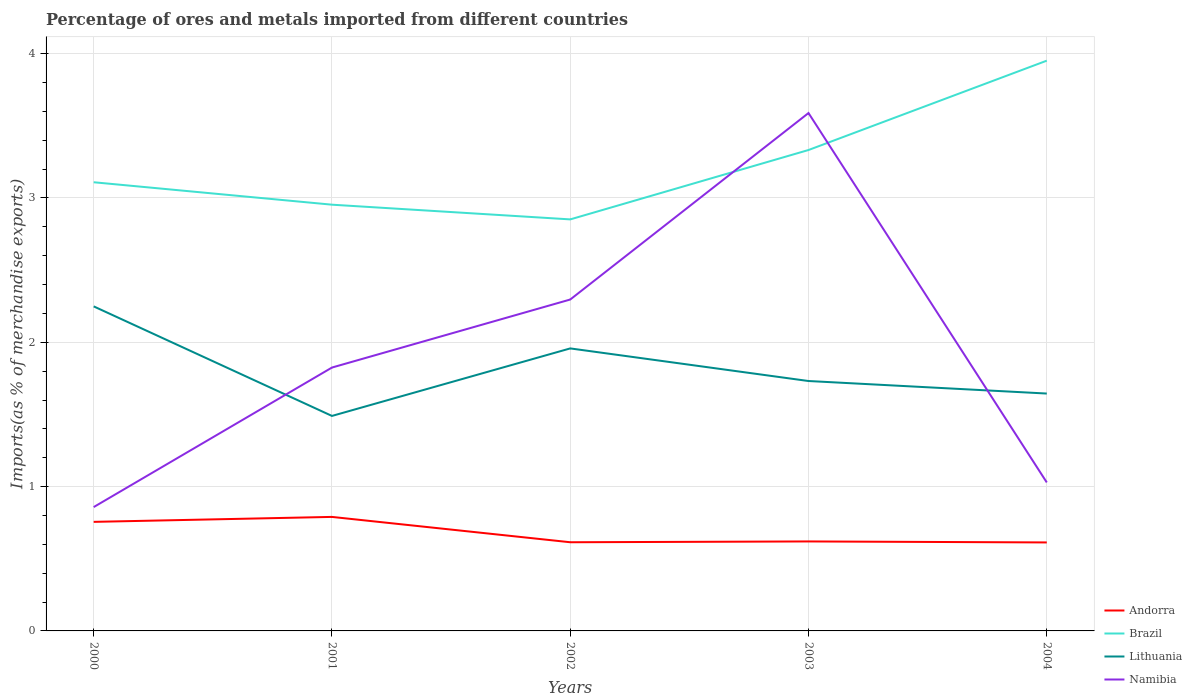How many different coloured lines are there?
Ensure brevity in your answer.  4. Does the line corresponding to Namibia intersect with the line corresponding to Brazil?
Make the answer very short. Yes. Is the number of lines equal to the number of legend labels?
Make the answer very short. Yes. Across all years, what is the maximum percentage of imports to different countries in Andorra?
Give a very brief answer. 0.61. What is the total percentage of imports to different countries in Andorra in the graph?
Ensure brevity in your answer.  0.18. What is the difference between the highest and the second highest percentage of imports to different countries in Andorra?
Provide a short and direct response. 0.18. What is the difference between the highest and the lowest percentage of imports to different countries in Lithuania?
Your response must be concise. 2. Is the percentage of imports to different countries in Lithuania strictly greater than the percentage of imports to different countries in Namibia over the years?
Keep it short and to the point. No. Are the values on the major ticks of Y-axis written in scientific E-notation?
Your answer should be compact. No. Does the graph contain any zero values?
Give a very brief answer. No. Does the graph contain grids?
Provide a succinct answer. Yes. What is the title of the graph?
Your response must be concise. Percentage of ores and metals imported from different countries. What is the label or title of the X-axis?
Provide a succinct answer. Years. What is the label or title of the Y-axis?
Your response must be concise. Imports(as % of merchandise exports). What is the Imports(as % of merchandise exports) in Andorra in 2000?
Ensure brevity in your answer.  0.76. What is the Imports(as % of merchandise exports) of Brazil in 2000?
Provide a short and direct response. 3.11. What is the Imports(as % of merchandise exports) in Lithuania in 2000?
Provide a short and direct response. 2.25. What is the Imports(as % of merchandise exports) of Namibia in 2000?
Ensure brevity in your answer.  0.86. What is the Imports(as % of merchandise exports) in Andorra in 2001?
Keep it short and to the point. 0.79. What is the Imports(as % of merchandise exports) of Brazil in 2001?
Your answer should be compact. 2.95. What is the Imports(as % of merchandise exports) of Lithuania in 2001?
Give a very brief answer. 1.49. What is the Imports(as % of merchandise exports) in Namibia in 2001?
Give a very brief answer. 1.82. What is the Imports(as % of merchandise exports) of Andorra in 2002?
Give a very brief answer. 0.61. What is the Imports(as % of merchandise exports) in Brazil in 2002?
Offer a very short reply. 2.85. What is the Imports(as % of merchandise exports) of Lithuania in 2002?
Ensure brevity in your answer.  1.96. What is the Imports(as % of merchandise exports) in Namibia in 2002?
Ensure brevity in your answer.  2.3. What is the Imports(as % of merchandise exports) of Andorra in 2003?
Give a very brief answer. 0.62. What is the Imports(as % of merchandise exports) of Brazil in 2003?
Your response must be concise. 3.33. What is the Imports(as % of merchandise exports) in Lithuania in 2003?
Ensure brevity in your answer.  1.73. What is the Imports(as % of merchandise exports) of Namibia in 2003?
Your answer should be very brief. 3.59. What is the Imports(as % of merchandise exports) of Andorra in 2004?
Give a very brief answer. 0.61. What is the Imports(as % of merchandise exports) of Brazil in 2004?
Offer a very short reply. 3.95. What is the Imports(as % of merchandise exports) of Lithuania in 2004?
Your answer should be very brief. 1.64. What is the Imports(as % of merchandise exports) in Namibia in 2004?
Make the answer very short. 1.03. Across all years, what is the maximum Imports(as % of merchandise exports) of Andorra?
Provide a succinct answer. 0.79. Across all years, what is the maximum Imports(as % of merchandise exports) in Brazil?
Make the answer very short. 3.95. Across all years, what is the maximum Imports(as % of merchandise exports) in Lithuania?
Your answer should be very brief. 2.25. Across all years, what is the maximum Imports(as % of merchandise exports) in Namibia?
Your answer should be very brief. 3.59. Across all years, what is the minimum Imports(as % of merchandise exports) of Andorra?
Ensure brevity in your answer.  0.61. Across all years, what is the minimum Imports(as % of merchandise exports) in Brazil?
Your answer should be very brief. 2.85. Across all years, what is the minimum Imports(as % of merchandise exports) of Lithuania?
Your answer should be very brief. 1.49. Across all years, what is the minimum Imports(as % of merchandise exports) of Namibia?
Keep it short and to the point. 0.86. What is the total Imports(as % of merchandise exports) of Andorra in the graph?
Give a very brief answer. 3.39. What is the total Imports(as % of merchandise exports) in Brazil in the graph?
Your response must be concise. 16.2. What is the total Imports(as % of merchandise exports) in Lithuania in the graph?
Keep it short and to the point. 9.07. What is the total Imports(as % of merchandise exports) in Namibia in the graph?
Provide a short and direct response. 9.6. What is the difference between the Imports(as % of merchandise exports) in Andorra in 2000 and that in 2001?
Make the answer very short. -0.03. What is the difference between the Imports(as % of merchandise exports) in Brazil in 2000 and that in 2001?
Your response must be concise. 0.16. What is the difference between the Imports(as % of merchandise exports) of Lithuania in 2000 and that in 2001?
Make the answer very short. 0.76. What is the difference between the Imports(as % of merchandise exports) in Namibia in 2000 and that in 2001?
Ensure brevity in your answer.  -0.97. What is the difference between the Imports(as % of merchandise exports) of Andorra in 2000 and that in 2002?
Give a very brief answer. 0.14. What is the difference between the Imports(as % of merchandise exports) of Brazil in 2000 and that in 2002?
Make the answer very short. 0.26. What is the difference between the Imports(as % of merchandise exports) of Lithuania in 2000 and that in 2002?
Offer a very short reply. 0.29. What is the difference between the Imports(as % of merchandise exports) of Namibia in 2000 and that in 2002?
Provide a short and direct response. -1.44. What is the difference between the Imports(as % of merchandise exports) of Andorra in 2000 and that in 2003?
Give a very brief answer. 0.14. What is the difference between the Imports(as % of merchandise exports) in Brazil in 2000 and that in 2003?
Offer a very short reply. -0.22. What is the difference between the Imports(as % of merchandise exports) in Lithuania in 2000 and that in 2003?
Your answer should be compact. 0.52. What is the difference between the Imports(as % of merchandise exports) of Namibia in 2000 and that in 2003?
Your answer should be compact. -2.73. What is the difference between the Imports(as % of merchandise exports) of Andorra in 2000 and that in 2004?
Your answer should be very brief. 0.14. What is the difference between the Imports(as % of merchandise exports) of Brazil in 2000 and that in 2004?
Offer a terse response. -0.84. What is the difference between the Imports(as % of merchandise exports) in Lithuania in 2000 and that in 2004?
Give a very brief answer. 0.6. What is the difference between the Imports(as % of merchandise exports) of Namibia in 2000 and that in 2004?
Provide a succinct answer. -0.17. What is the difference between the Imports(as % of merchandise exports) of Andorra in 2001 and that in 2002?
Offer a terse response. 0.18. What is the difference between the Imports(as % of merchandise exports) in Brazil in 2001 and that in 2002?
Provide a short and direct response. 0.1. What is the difference between the Imports(as % of merchandise exports) of Lithuania in 2001 and that in 2002?
Give a very brief answer. -0.47. What is the difference between the Imports(as % of merchandise exports) in Namibia in 2001 and that in 2002?
Keep it short and to the point. -0.47. What is the difference between the Imports(as % of merchandise exports) in Andorra in 2001 and that in 2003?
Offer a terse response. 0.17. What is the difference between the Imports(as % of merchandise exports) of Brazil in 2001 and that in 2003?
Ensure brevity in your answer.  -0.38. What is the difference between the Imports(as % of merchandise exports) in Lithuania in 2001 and that in 2003?
Offer a terse response. -0.24. What is the difference between the Imports(as % of merchandise exports) in Namibia in 2001 and that in 2003?
Provide a short and direct response. -1.76. What is the difference between the Imports(as % of merchandise exports) of Andorra in 2001 and that in 2004?
Keep it short and to the point. 0.18. What is the difference between the Imports(as % of merchandise exports) of Brazil in 2001 and that in 2004?
Your response must be concise. -1. What is the difference between the Imports(as % of merchandise exports) in Lithuania in 2001 and that in 2004?
Provide a short and direct response. -0.16. What is the difference between the Imports(as % of merchandise exports) in Namibia in 2001 and that in 2004?
Give a very brief answer. 0.8. What is the difference between the Imports(as % of merchandise exports) of Andorra in 2002 and that in 2003?
Your answer should be very brief. -0.01. What is the difference between the Imports(as % of merchandise exports) in Brazil in 2002 and that in 2003?
Your answer should be compact. -0.48. What is the difference between the Imports(as % of merchandise exports) of Lithuania in 2002 and that in 2003?
Your response must be concise. 0.23. What is the difference between the Imports(as % of merchandise exports) in Namibia in 2002 and that in 2003?
Your answer should be compact. -1.29. What is the difference between the Imports(as % of merchandise exports) in Andorra in 2002 and that in 2004?
Make the answer very short. 0. What is the difference between the Imports(as % of merchandise exports) of Brazil in 2002 and that in 2004?
Provide a short and direct response. -1.1. What is the difference between the Imports(as % of merchandise exports) of Lithuania in 2002 and that in 2004?
Ensure brevity in your answer.  0.31. What is the difference between the Imports(as % of merchandise exports) of Namibia in 2002 and that in 2004?
Give a very brief answer. 1.27. What is the difference between the Imports(as % of merchandise exports) in Andorra in 2003 and that in 2004?
Provide a short and direct response. 0.01. What is the difference between the Imports(as % of merchandise exports) in Brazil in 2003 and that in 2004?
Provide a succinct answer. -0.62. What is the difference between the Imports(as % of merchandise exports) of Lithuania in 2003 and that in 2004?
Your answer should be compact. 0.09. What is the difference between the Imports(as % of merchandise exports) of Namibia in 2003 and that in 2004?
Provide a succinct answer. 2.56. What is the difference between the Imports(as % of merchandise exports) in Andorra in 2000 and the Imports(as % of merchandise exports) in Brazil in 2001?
Provide a succinct answer. -2.2. What is the difference between the Imports(as % of merchandise exports) in Andorra in 2000 and the Imports(as % of merchandise exports) in Lithuania in 2001?
Give a very brief answer. -0.73. What is the difference between the Imports(as % of merchandise exports) of Andorra in 2000 and the Imports(as % of merchandise exports) of Namibia in 2001?
Give a very brief answer. -1.07. What is the difference between the Imports(as % of merchandise exports) of Brazil in 2000 and the Imports(as % of merchandise exports) of Lithuania in 2001?
Make the answer very short. 1.62. What is the difference between the Imports(as % of merchandise exports) in Brazil in 2000 and the Imports(as % of merchandise exports) in Namibia in 2001?
Provide a short and direct response. 1.28. What is the difference between the Imports(as % of merchandise exports) in Lithuania in 2000 and the Imports(as % of merchandise exports) in Namibia in 2001?
Keep it short and to the point. 0.42. What is the difference between the Imports(as % of merchandise exports) of Andorra in 2000 and the Imports(as % of merchandise exports) of Brazil in 2002?
Offer a terse response. -2.1. What is the difference between the Imports(as % of merchandise exports) of Andorra in 2000 and the Imports(as % of merchandise exports) of Lithuania in 2002?
Provide a short and direct response. -1.2. What is the difference between the Imports(as % of merchandise exports) of Andorra in 2000 and the Imports(as % of merchandise exports) of Namibia in 2002?
Ensure brevity in your answer.  -1.54. What is the difference between the Imports(as % of merchandise exports) of Brazil in 2000 and the Imports(as % of merchandise exports) of Lithuania in 2002?
Your response must be concise. 1.15. What is the difference between the Imports(as % of merchandise exports) of Brazil in 2000 and the Imports(as % of merchandise exports) of Namibia in 2002?
Provide a succinct answer. 0.81. What is the difference between the Imports(as % of merchandise exports) in Lithuania in 2000 and the Imports(as % of merchandise exports) in Namibia in 2002?
Give a very brief answer. -0.05. What is the difference between the Imports(as % of merchandise exports) of Andorra in 2000 and the Imports(as % of merchandise exports) of Brazil in 2003?
Your answer should be very brief. -2.58. What is the difference between the Imports(as % of merchandise exports) of Andorra in 2000 and the Imports(as % of merchandise exports) of Lithuania in 2003?
Ensure brevity in your answer.  -0.98. What is the difference between the Imports(as % of merchandise exports) in Andorra in 2000 and the Imports(as % of merchandise exports) in Namibia in 2003?
Your answer should be compact. -2.83. What is the difference between the Imports(as % of merchandise exports) in Brazil in 2000 and the Imports(as % of merchandise exports) in Lithuania in 2003?
Ensure brevity in your answer.  1.38. What is the difference between the Imports(as % of merchandise exports) of Brazil in 2000 and the Imports(as % of merchandise exports) of Namibia in 2003?
Offer a very short reply. -0.48. What is the difference between the Imports(as % of merchandise exports) in Lithuania in 2000 and the Imports(as % of merchandise exports) in Namibia in 2003?
Your response must be concise. -1.34. What is the difference between the Imports(as % of merchandise exports) of Andorra in 2000 and the Imports(as % of merchandise exports) of Brazil in 2004?
Provide a short and direct response. -3.2. What is the difference between the Imports(as % of merchandise exports) of Andorra in 2000 and the Imports(as % of merchandise exports) of Lithuania in 2004?
Keep it short and to the point. -0.89. What is the difference between the Imports(as % of merchandise exports) of Andorra in 2000 and the Imports(as % of merchandise exports) of Namibia in 2004?
Your response must be concise. -0.27. What is the difference between the Imports(as % of merchandise exports) in Brazil in 2000 and the Imports(as % of merchandise exports) in Lithuania in 2004?
Your response must be concise. 1.46. What is the difference between the Imports(as % of merchandise exports) of Brazil in 2000 and the Imports(as % of merchandise exports) of Namibia in 2004?
Ensure brevity in your answer.  2.08. What is the difference between the Imports(as % of merchandise exports) of Lithuania in 2000 and the Imports(as % of merchandise exports) of Namibia in 2004?
Your answer should be very brief. 1.22. What is the difference between the Imports(as % of merchandise exports) of Andorra in 2001 and the Imports(as % of merchandise exports) of Brazil in 2002?
Make the answer very short. -2.06. What is the difference between the Imports(as % of merchandise exports) in Andorra in 2001 and the Imports(as % of merchandise exports) in Lithuania in 2002?
Offer a terse response. -1.17. What is the difference between the Imports(as % of merchandise exports) in Andorra in 2001 and the Imports(as % of merchandise exports) in Namibia in 2002?
Keep it short and to the point. -1.51. What is the difference between the Imports(as % of merchandise exports) in Brazil in 2001 and the Imports(as % of merchandise exports) in Lithuania in 2002?
Offer a terse response. 1. What is the difference between the Imports(as % of merchandise exports) in Brazil in 2001 and the Imports(as % of merchandise exports) in Namibia in 2002?
Ensure brevity in your answer.  0.66. What is the difference between the Imports(as % of merchandise exports) of Lithuania in 2001 and the Imports(as % of merchandise exports) of Namibia in 2002?
Keep it short and to the point. -0.81. What is the difference between the Imports(as % of merchandise exports) in Andorra in 2001 and the Imports(as % of merchandise exports) in Brazil in 2003?
Your answer should be very brief. -2.54. What is the difference between the Imports(as % of merchandise exports) in Andorra in 2001 and the Imports(as % of merchandise exports) in Lithuania in 2003?
Give a very brief answer. -0.94. What is the difference between the Imports(as % of merchandise exports) of Andorra in 2001 and the Imports(as % of merchandise exports) of Namibia in 2003?
Make the answer very short. -2.8. What is the difference between the Imports(as % of merchandise exports) of Brazil in 2001 and the Imports(as % of merchandise exports) of Lithuania in 2003?
Your answer should be very brief. 1.22. What is the difference between the Imports(as % of merchandise exports) of Brazil in 2001 and the Imports(as % of merchandise exports) of Namibia in 2003?
Make the answer very short. -0.64. What is the difference between the Imports(as % of merchandise exports) in Lithuania in 2001 and the Imports(as % of merchandise exports) in Namibia in 2003?
Keep it short and to the point. -2.1. What is the difference between the Imports(as % of merchandise exports) of Andorra in 2001 and the Imports(as % of merchandise exports) of Brazil in 2004?
Your answer should be compact. -3.16. What is the difference between the Imports(as % of merchandise exports) in Andorra in 2001 and the Imports(as % of merchandise exports) in Lithuania in 2004?
Make the answer very short. -0.85. What is the difference between the Imports(as % of merchandise exports) of Andorra in 2001 and the Imports(as % of merchandise exports) of Namibia in 2004?
Provide a short and direct response. -0.24. What is the difference between the Imports(as % of merchandise exports) of Brazil in 2001 and the Imports(as % of merchandise exports) of Lithuania in 2004?
Make the answer very short. 1.31. What is the difference between the Imports(as % of merchandise exports) of Brazil in 2001 and the Imports(as % of merchandise exports) of Namibia in 2004?
Give a very brief answer. 1.92. What is the difference between the Imports(as % of merchandise exports) of Lithuania in 2001 and the Imports(as % of merchandise exports) of Namibia in 2004?
Ensure brevity in your answer.  0.46. What is the difference between the Imports(as % of merchandise exports) of Andorra in 2002 and the Imports(as % of merchandise exports) of Brazil in 2003?
Your answer should be very brief. -2.72. What is the difference between the Imports(as % of merchandise exports) in Andorra in 2002 and the Imports(as % of merchandise exports) in Lithuania in 2003?
Make the answer very short. -1.12. What is the difference between the Imports(as % of merchandise exports) in Andorra in 2002 and the Imports(as % of merchandise exports) in Namibia in 2003?
Provide a short and direct response. -2.97. What is the difference between the Imports(as % of merchandise exports) of Brazil in 2002 and the Imports(as % of merchandise exports) of Lithuania in 2003?
Provide a succinct answer. 1.12. What is the difference between the Imports(as % of merchandise exports) of Brazil in 2002 and the Imports(as % of merchandise exports) of Namibia in 2003?
Provide a succinct answer. -0.74. What is the difference between the Imports(as % of merchandise exports) in Lithuania in 2002 and the Imports(as % of merchandise exports) in Namibia in 2003?
Offer a terse response. -1.63. What is the difference between the Imports(as % of merchandise exports) in Andorra in 2002 and the Imports(as % of merchandise exports) in Brazil in 2004?
Give a very brief answer. -3.34. What is the difference between the Imports(as % of merchandise exports) in Andorra in 2002 and the Imports(as % of merchandise exports) in Lithuania in 2004?
Provide a short and direct response. -1.03. What is the difference between the Imports(as % of merchandise exports) in Andorra in 2002 and the Imports(as % of merchandise exports) in Namibia in 2004?
Offer a very short reply. -0.41. What is the difference between the Imports(as % of merchandise exports) of Brazil in 2002 and the Imports(as % of merchandise exports) of Lithuania in 2004?
Keep it short and to the point. 1.21. What is the difference between the Imports(as % of merchandise exports) in Brazil in 2002 and the Imports(as % of merchandise exports) in Namibia in 2004?
Provide a short and direct response. 1.82. What is the difference between the Imports(as % of merchandise exports) in Lithuania in 2002 and the Imports(as % of merchandise exports) in Namibia in 2004?
Give a very brief answer. 0.93. What is the difference between the Imports(as % of merchandise exports) of Andorra in 2003 and the Imports(as % of merchandise exports) of Brazil in 2004?
Offer a very short reply. -3.33. What is the difference between the Imports(as % of merchandise exports) in Andorra in 2003 and the Imports(as % of merchandise exports) in Lithuania in 2004?
Provide a succinct answer. -1.02. What is the difference between the Imports(as % of merchandise exports) in Andorra in 2003 and the Imports(as % of merchandise exports) in Namibia in 2004?
Keep it short and to the point. -0.41. What is the difference between the Imports(as % of merchandise exports) of Brazil in 2003 and the Imports(as % of merchandise exports) of Lithuania in 2004?
Your response must be concise. 1.69. What is the difference between the Imports(as % of merchandise exports) of Brazil in 2003 and the Imports(as % of merchandise exports) of Namibia in 2004?
Ensure brevity in your answer.  2.3. What is the difference between the Imports(as % of merchandise exports) of Lithuania in 2003 and the Imports(as % of merchandise exports) of Namibia in 2004?
Make the answer very short. 0.7. What is the average Imports(as % of merchandise exports) of Andorra per year?
Offer a terse response. 0.68. What is the average Imports(as % of merchandise exports) of Brazil per year?
Give a very brief answer. 3.24. What is the average Imports(as % of merchandise exports) in Lithuania per year?
Give a very brief answer. 1.81. What is the average Imports(as % of merchandise exports) of Namibia per year?
Give a very brief answer. 1.92. In the year 2000, what is the difference between the Imports(as % of merchandise exports) of Andorra and Imports(as % of merchandise exports) of Brazil?
Offer a very short reply. -2.35. In the year 2000, what is the difference between the Imports(as % of merchandise exports) in Andorra and Imports(as % of merchandise exports) in Lithuania?
Give a very brief answer. -1.49. In the year 2000, what is the difference between the Imports(as % of merchandise exports) in Andorra and Imports(as % of merchandise exports) in Namibia?
Keep it short and to the point. -0.1. In the year 2000, what is the difference between the Imports(as % of merchandise exports) of Brazil and Imports(as % of merchandise exports) of Lithuania?
Give a very brief answer. 0.86. In the year 2000, what is the difference between the Imports(as % of merchandise exports) in Brazil and Imports(as % of merchandise exports) in Namibia?
Your answer should be compact. 2.25. In the year 2000, what is the difference between the Imports(as % of merchandise exports) in Lithuania and Imports(as % of merchandise exports) in Namibia?
Provide a succinct answer. 1.39. In the year 2001, what is the difference between the Imports(as % of merchandise exports) of Andorra and Imports(as % of merchandise exports) of Brazil?
Offer a terse response. -2.16. In the year 2001, what is the difference between the Imports(as % of merchandise exports) of Andorra and Imports(as % of merchandise exports) of Lithuania?
Provide a succinct answer. -0.7. In the year 2001, what is the difference between the Imports(as % of merchandise exports) of Andorra and Imports(as % of merchandise exports) of Namibia?
Give a very brief answer. -1.03. In the year 2001, what is the difference between the Imports(as % of merchandise exports) in Brazil and Imports(as % of merchandise exports) in Lithuania?
Provide a succinct answer. 1.46. In the year 2001, what is the difference between the Imports(as % of merchandise exports) of Brazil and Imports(as % of merchandise exports) of Namibia?
Make the answer very short. 1.13. In the year 2001, what is the difference between the Imports(as % of merchandise exports) in Lithuania and Imports(as % of merchandise exports) in Namibia?
Ensure brevity in your answer.  -0.34. In the year 2002, what is the difference between the Imports(as % of merchandise exports) of Andorra and Imports(as % of merchandise exports) of Brazil?
Keep it short and to the point. -2.24. In the year 2002, what is the difference between the Imports(as % of merchandise exports) in Andorra and Imports(as % of merchandise exports) in Lithuania?
Offer a terse response. -1.34. In the year 2002, what is the difference between the Imports(as % of merchandise exports) of Andorra and Imports(as % of merchandise exports) of Namibia?
Your response must be concise. -1.68. In the year 2002, what is the difference between the Imports(as % of merchandise exports) of Brazil and Imports(as % of merchandise exports) of Lithuania?
Your response must be concise. 0.89. In the year 2002, what is the difference between the Imports(as % of merchandise exports) of Brazil and Imports(as % of merchandise exports) of Namibia?
Ensure brevity in your answer.  0.56. In the year 2002, what is the difference between the Imports(as % of merchandise exports) of Lithuania and Imports(as % of merchandise exports) of Namibia?
Offer a terse response. -0.34. In the year 2003, what is the difference between the Imports(as % of merchandise exports) of Andorra and Imports(as % of merchandise exports) of Brazil?
Provide a succinct answer. -2.71. In the year 2003, what is the difference between the Imports(as % of merchandise exports) in Andorra and Imports(as % of merchandise exports) in Lithuania?
Provide a short and direct response. -1.11. In the year 2003, what is the difference between the Imports(as % of merchandise exports) of Andorra and Imports(as % of merchandise exports) of Namibia?
Your response must be concise. -2.97. In the year 2003, what is the difference between the Imports(as % of merchandise exports) of Brazil and Imports(as % of merchandise exports) of Lithuania?
Your answer should be compact. 1.6. In the year 2003, what is the difference between the Imports(as % of merchandise exports) of Brazil and Imports(as % of merchandise exports) of Namibia?
Make the answer very short. -0.26. In the year 2003, what is the difference between the Imports(as % of merchandise exports) of Lithuania and Imports(as % of merchandise exports) of Namibia?
Provide a succinct answer. -1.86. In the year 2004, what is the difference between the Imports(as % of merchandise exports) in Andorra and Imports(as % of merchandise exports) in Brazil?
Offer a terse response. -3.34. In the year 2004, what is the difference between the Imports(as % of merchandise exports) of Andorra and Imports(as % of merchandise exports) of Lithuania?
Provide a succinct answer. -1.03. In the year 2004, what is the difference between the Imports(as % of merchandise exports) of Andorra and Imports(as % of merchandise exports) of Namibia?
Offer a terse response. -0.42. In the year 2004, what is the difference between the Imports(as % of merchandise exports) of Brazil and Imports(as % of merchandise exports) of Lithuania?
Give a very brief answer. 2.31. In the year 2004, what is the difference between the Imports(as % of merchandise exports) in Brazil and Imports(as % of merchandise exports) in Namibia?
Offer a very short reply. 2.92. In the year 2004, what is the difference between the Imports(as % of merchandise exports) in Lithuania and Imports(as % of merchandise exports) in Namibia?
Your response must be concise. 0.62. What is the ratio of the Imports(as % of merchandise exports) of Andorra in 2000 to that in 2001?
Offer a terse response. 0.96. What is the ratio of the Imports(as % of merchandise exports) of Brazil in 2000 to that in 2001?
Give a very brief answer. 1.05. What is the ratio of the Imports(as % of merchandise exports) in Lithuania in 2000 to that in 2001?
Your response must be concise. 1.51. What is the ratio of the Imports(as % of merchandise exports) in Namibia in 2000 to that in 2001?
Provide a short and direct response. 0.47. What is the ratio of the Imports(as % of merchandise exports) of Andorra in 2000 to that in 2002?
Provide a succinct answer. 1.23. What is the ratio of the Imports(as % of merchandise exports) in Brazil in 2000 to that in 2002?
Make the answer very short. 1.09. What is the ratio of the Imports(as % of merchandise exports) of Lithuania in 2000 to that in 2002?
Your answer should be compact. 1.15. What is the ratio of the Imports(as % of merchandise exports) of Namibia in 2000 to that in 2002?
Ensure brevity in your answer.  0.37. What is the ratio of the Imports(as % of merchandise exports) of Andorra in 2000 to that in 2003?
Give a very brief answer. 1.22. What is the ratio of the Imports(as % of merchandise exports) of Brazil in 2000 to that in 2003?
Make the answer very short. 0.93. What is the ratio of the Imports(as % of merchandise exports) of Lithuania in 2000 to that in 2003?
Your response must be concise. 1.3. What is the ratio of the Imports(as % of merchandise exports) of Namibia in 2000 to that in 2003?
Offer a terse response. 0.24. What is the ratio of the Imports(as % of merchandise exports) in Andorra in 2000 to that in 2004?
Offer a very short reply. 1.23. What is the ratio of the Imports(as % of merchandise exports) in Brazil in 2000 to that in 2004?
Your answer should be very brief. 0.79. What is the ratio of the Imports(as % of merchandise exports) in Lithuania in 2000 to that in 2004?
Your answer should be very brief. 1.37. What is the ratio of the Imports(as % of merchandise exports) of Namibia in 2000 to that in 2004?
Ensure brevity in your answer.  0.83. What is the ratio of the Imports(as % of merchandise exports) in Brazil in 2001 to that in 2002?
Your response must be concise. 1.04. What is the ratio of the Imports(as % of merchandise exports) of Lithuania in 2001 to that in 2002?
Provide a succinct answer. 0.76. What is the ratio of the Imports(as % of merchandise exports) in Namibia in 2001 to that in 2002?
Your answer should be very brief. 0.79. What is the ratio of the Imports(as % of merchandise exports) in Andorra in 2001 to that in 2003?
Your answer should be compact. 1.27. What is the ratio of the Imports(as % of merchandise exports) in Brazil in 2001 to that in 2003?
Offer a very short reply. 0.89. What is the ratio of the Imports(as % of merchandise exports) of Lithuania in 2001 to that in 2003?
Your answer should be very brief. 0.86. What is the ratio of the Imports(as % of merchandise exports) in Namibia in 2001 to that in 2003?
Give a very brief answer. 0.51. What is the ratio of the Imports(as % of merchandise exports) of Andorra in 2001 to that in 2004?
Provide a short and direct response. 1.29. What is the ratio of the Imports(as % of merchandise exports) in Brazil in 2001 to that in 2004?
Ensure brevity in your answer.  0.75. What is the ratio of the Imports(as % of merchandise exports) of Lithuania in 2001 to that in 2004?
Provide a succinct answer. 0.91. What is the ratio of the Imports(as % of merchandise exports) in Namibia in 2001 to that in 2004?
Make the answer very short. 1.77. What is the ratio of the Imports(as % of merchandise exports) in Brazil in 2002 to that in 2003?
Give a very brief answer. 0.86. What is the ratio of the Imports(as % of merchandise exports) of Lithuania in 2002 to that in 2003?
Provide a succinct answer. 1.13. What is the ratio of the Imports(as % of merchandise exports) in Namibia in 2002 to that in 2003?
Offer a very short reply. 0.64. What is the ratio of the Imports(as % of merchandise exports) of Andorra in 2002 to that in 2004?
Your answer should be very brief. 1. What is the ratio of the Imports(as % of merchandise exports) of Brazil in 2002 to that in 2004?
Make the answer very short. 0.72. What is the ratio of the Imports(as % of merchandise exports) of Lithuania in 2002 to that in 2004?
Your response must be concise. 1.19. What is the ratio of the Imports(as % of merchandise exports) in Namibia in 2002 to that in 2004?
Offer a terse response. 2.23. What is the ratio of the Imports(as % of merchandise exports) of Andorra in 2003 to that in 2004?
Ensure brevity in your answer.  1.01. What is the ratio of the Imports(as % of merchandise exports) of Brazil in 2003 to that in 2004?
Ensure brevity in your answer.  0.84. What is the ratio of the Imports(as % of merchandise exports) of Lithuania in 2003 to that in 2004?
Your answer should be very brief. 1.05. What is the ratio of the Imports(as % of merchandise exports) in Namibia in 2003 to that in 2004?
Offer a terse response. 3.49. What is the difference between the highest and the second highest Imports(as % of merchandise exports) of Andorra?
Provide a succinct answer. 0.03. What is the difference between the highest and the second highest Imports(as % of merchandise exports) of Brazil?
Give a very brief answer. 0.62. What is the difference between the highest and the second highest Imports(as % of merchandise exports) in Lithuania?
Ensure brevity in your answer.  0.29. What is the difference between the highest and the second highest Imports(as % of merchandise exports) of Namibia?
Make the answer very short. 1.29. What is the difference between the highest and the lowest Imports(as % of merchandise exports) in Andorra?
Offer a terse response. 0.18. What is the difference between the highest and the lowest Imports(as % of merchandise exports) in Brazil?
Your response must be concise. 1.1. What is the difference between the highest and the lowest Imports(as % of merchandise exports) in Lithuania?
Provide a succinct answer. 0.76. What is the difference between the highest and the lowest Imports(as % of merchandise exports) of Namibia?
Your response must be concise. 2.73. 